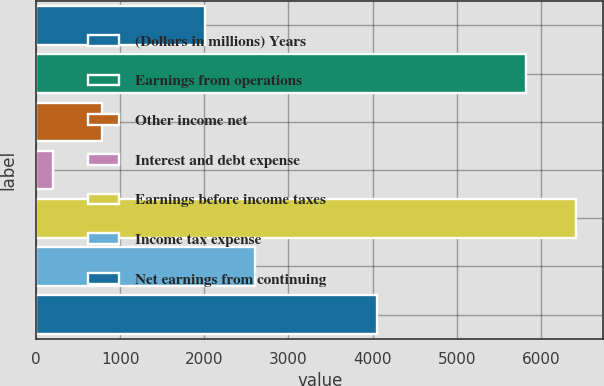Convert chart. <chart><loc_0><loc_0><loc_500><loc_500><bar_chart><fcel>(Dollars in millions) Years<fcel>Earnings from operations<fcel>Other income net<fcel>Interest and debt expense<fcel>Earnings before income taxes<fcel>Income tax expense<fcel>Net earnings from continuing<nl><fcel>2007<fcel>5830<fcel>788.2<fcel>196<fcel>6422.2<fcel>2599.2<fcel>4058<nl></chart> 